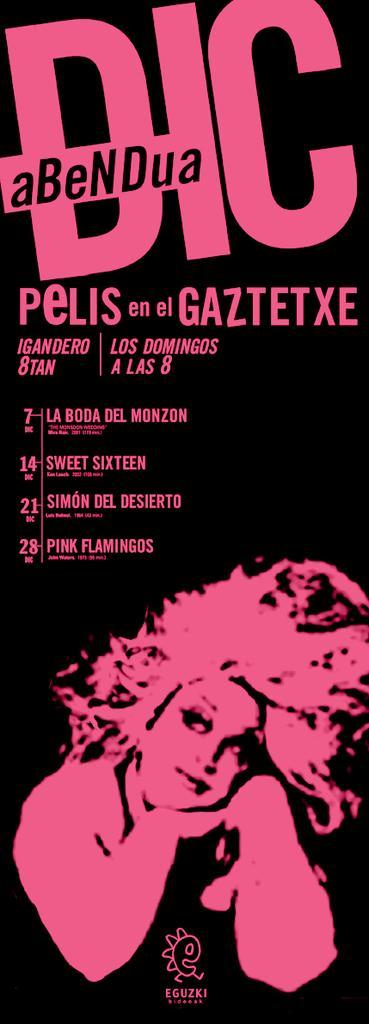Can you describe this image briefly? In this picture I can see a poster in front and I see something is written on it. On the bottom side of this poster I can see the depiction picture of a woman. 